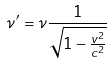<formula> <loc_0><loc_0><loc_500><loc_500>\nu ^ { \prime } = \nu \frac { 1 } { \sqrt { 1 - \frac { v ^ { 2 } } { c ^ { 2 } } } }</formula> 